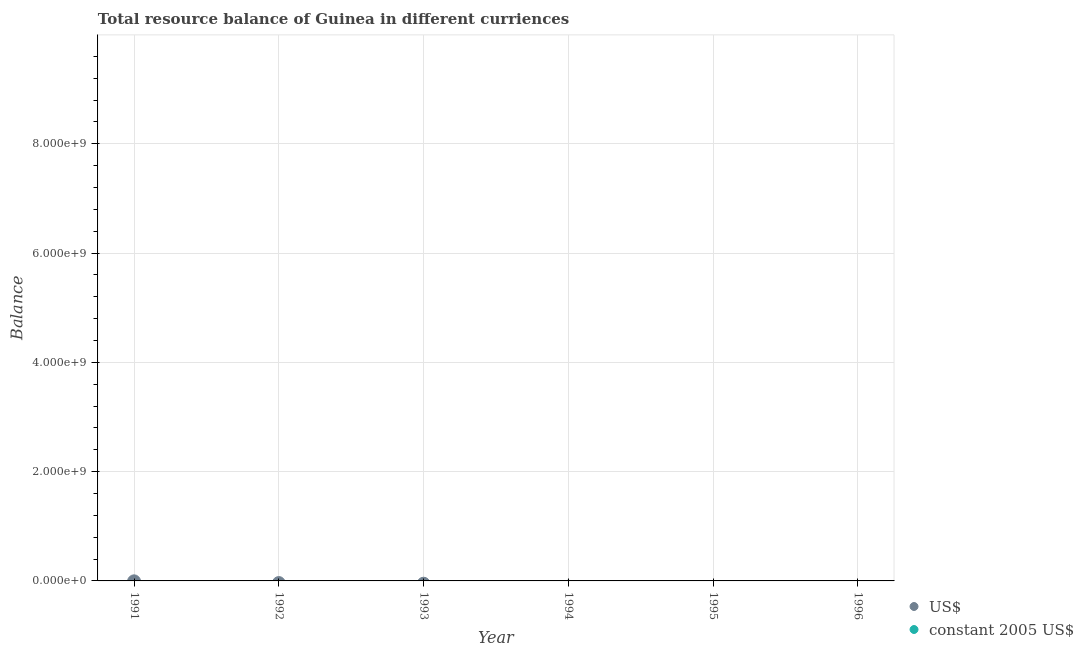What is the total resource balance in us$ in the graph?
Your answer should be compact. 0. What is the average resource balance in constant us$ per year?
Provide a succinct answer. 0. In how many years, is the resource balance in us$ greater than the average resource balance in us$ taken over all years?
Offer a terse response. 0. How many dotlines are there?
Offer a terse response. 0. What is the difference between two consecutive major ticks on the Y-axis?
Keep it short and to the point. 2.00e+09. How many legend labels are there?
Provide a short and direct response. 2. How are the legend labels stacked?
Provide a short and direct response. Vertical. What is the title of the graph?
Provide a short and direct response. Total resource balance of Guinea in different curriences. Does "Taxes on exports" appear as one of the legend labels in the graph?
Give a very brief answer. No. What is the label or title of the X-axis?
Make the answer very short. Year. What is the label or title of the Y-axis?
Provide a succinct answer. Balance. What is the Balance of US$ in 1991?
Make the answer very short. 0. What is the Balance in constant 2005 US$ in 1991?
Offer a very short reply. 0. What is the Balance of US$ in 1992?
Make the answer very short. 0. What is the Balance of US$ in 1993?
Keep it short and to the point. 0. What is the Balance of US$ in 1994?
Make the answer very short. 0. What is the Balance of constant 2005 US$ in 1994?
Offer a terse response. 0. What is the Balance of US$ in 1995?
Ensure brevity in your answer.  0. What is the Balance of constant 2005 US$ in 1996?
Offer a terse response. 0. What is the total Balance in constant 2005 US$ in the graph?
Keep it short and to the point. 0. What is the average Balance of constant 2005 US$ per year?
Offer a very short reply. 0. 